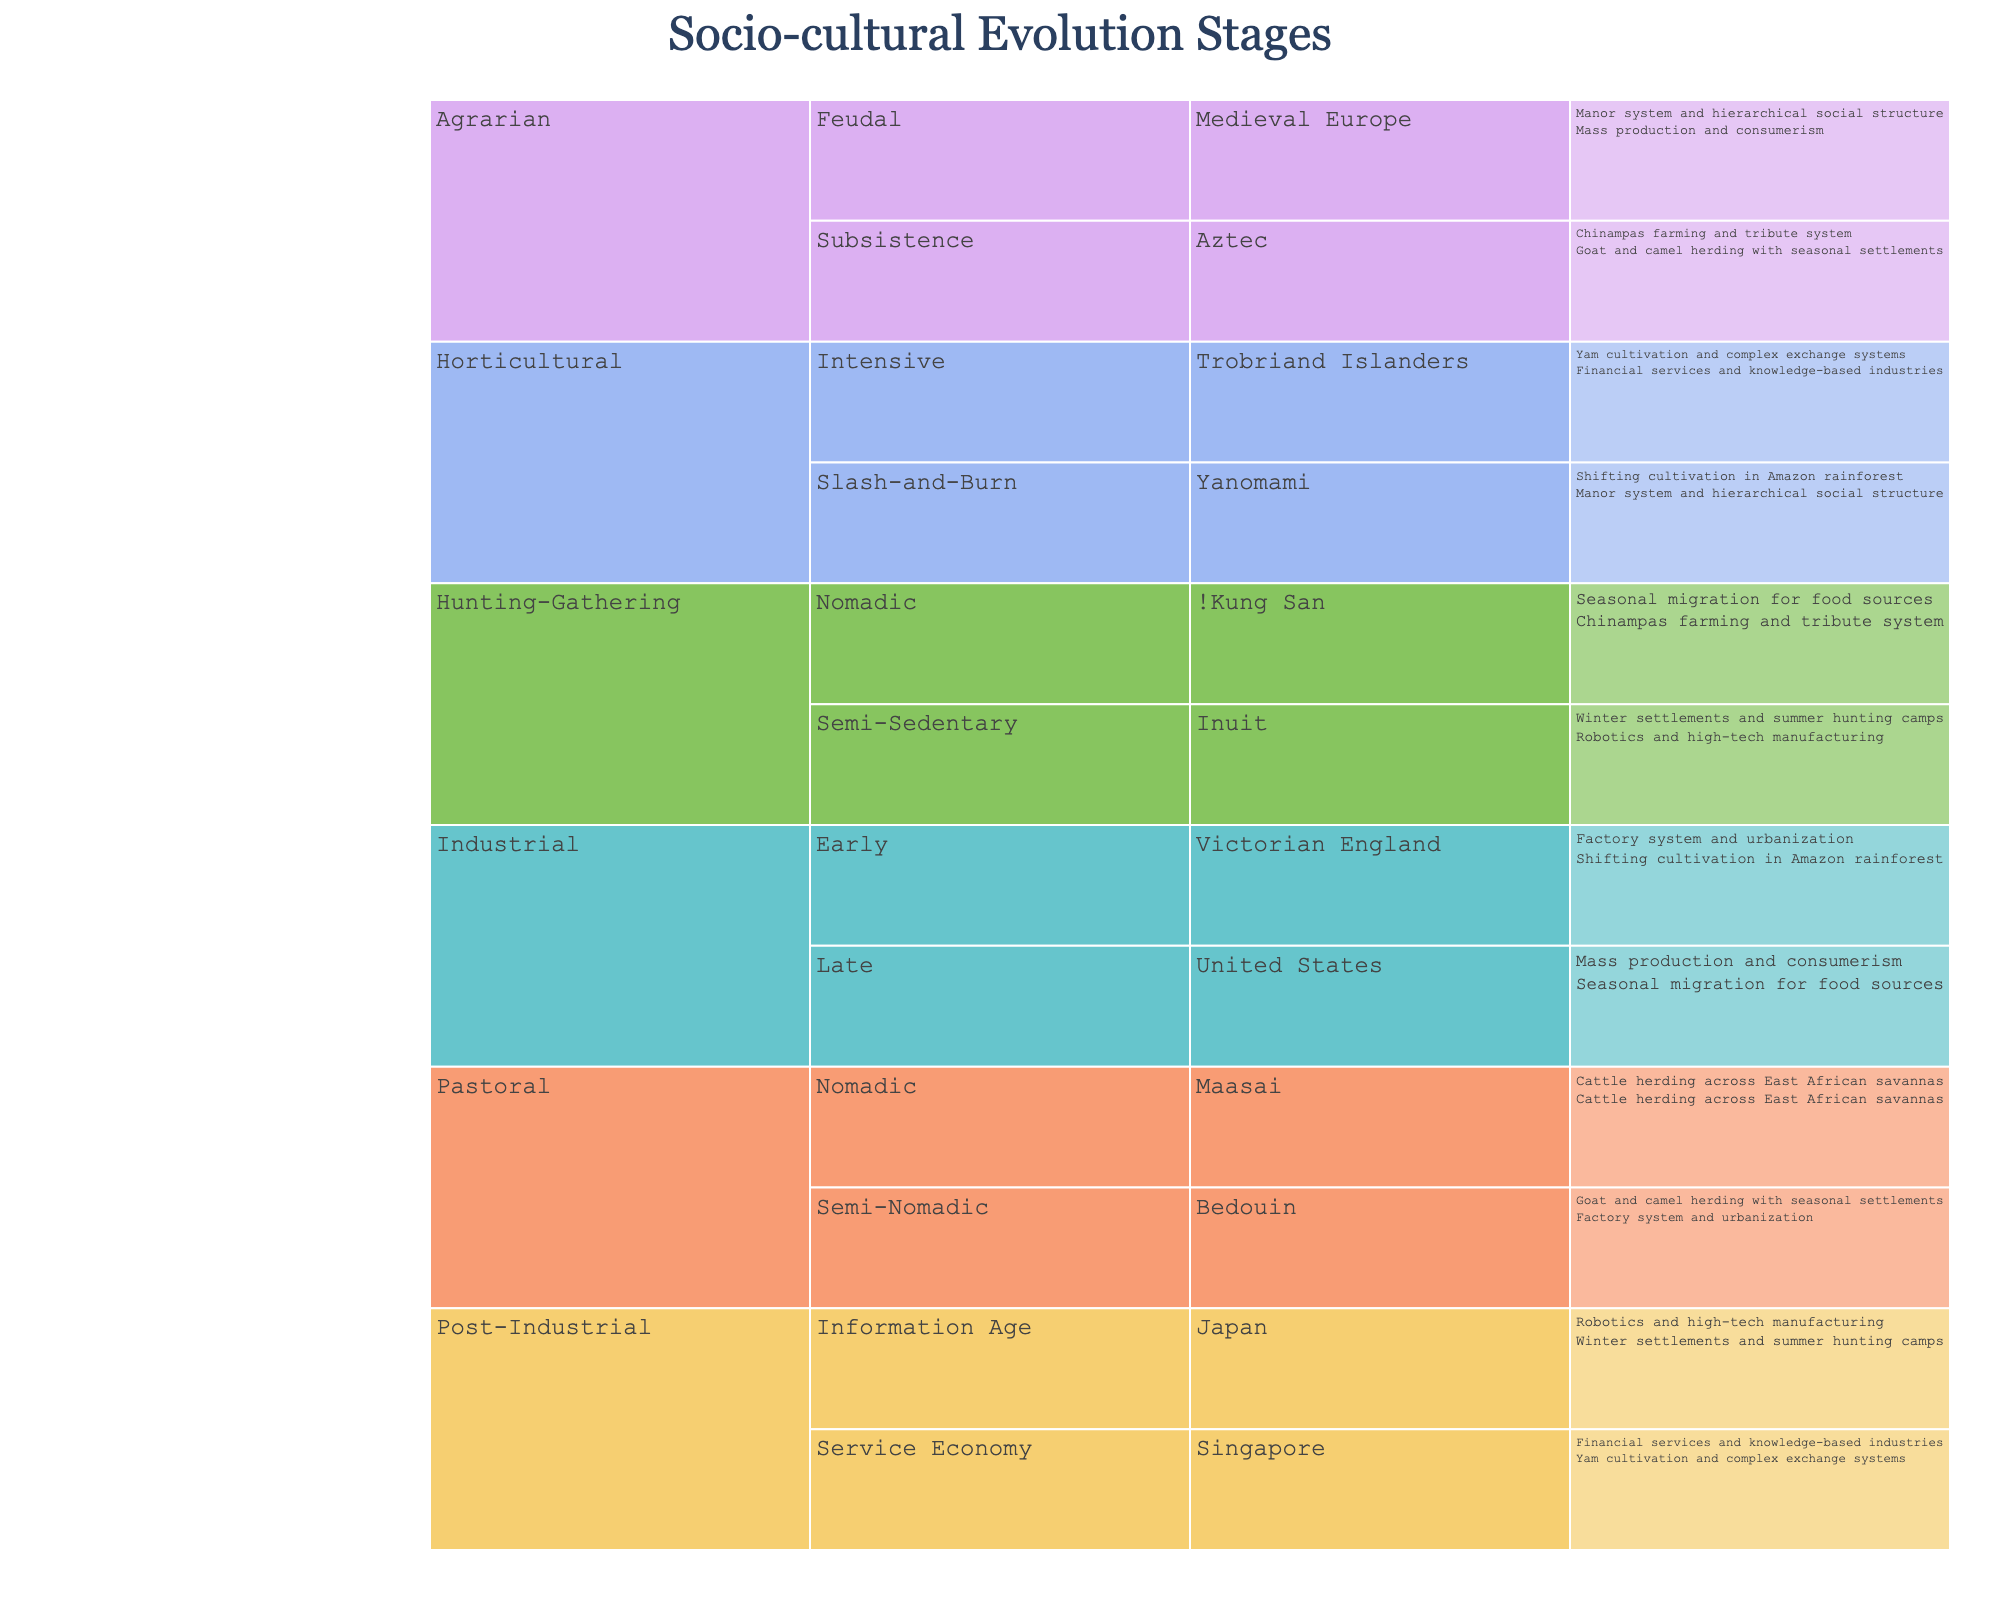How many main stages are there in the chart? The chart lists different social and cultural evolution stages, and by counting the main categories, we find five: Hunting-Gathering, Horticultural, Pastoral, Agrarian, Industrial, and Post-Industrial.
Answer: 6 Which society is associated with Slash-and-Burn Horticultural? By looking at the Icicle Chart, the Yanomami society is classified under the Slash-and-Burn sub-stage within the Horticultural stage.
Answer: Yanomami What are the two sub-stages under the Agrarian stage? The chart displays the sub-stages of the Agrarian stage by expanding it: Subsistence and Feudal.
Answer: Subsistence and Feudal Compare the activities associated with the Bedouin and Trobriand Islanders societies. How do they differ? The Bedouin society, under the Pastoral stage, Semi-Nomadic sub-stage, practices goat and camel herding with seasonal settlements, while the Trobriand Islanders, under Intensive Horticultural, focus on yam cultivation and complex exchange systems. These activities differ significantly: the former centers around herding, while the latter involves intensive agriculture and trade.
Answer: Bedouin: Goat and camel herding; Trobriand Islanders: Yam cultivation and complex exchange Which stage has societies practicing both subsistence farming and mass production? The Agrarian stage includes subsistence farming by the Aztecs, while the Industrial stage includes mass production by the United States. Additionally, by comparing these stages, we see both practices are represented across these distinct stages.
Answer: Agrarian and Industrial List all societies under the Post-Industrial stage and their respective examples. Under the Post-Industrial stage, there are two societies: Japan with robotics and high-tech manufacturing, and Singapore with financial services and knowledge-based industries.
Answer: Japan: robotics and high-tech manufacturing; Singapore: financial services and knowledge-based industries Which sub-stage under the Industrial stage represents early industrialization, and which society is an example? The early sub-stage of the Industrial stage is represented by Victorian England, which is associated with the factory system and urbanization.
Answer: Early: Victorian England How does the Trobriand Islanders' example of human activity differ from that of the Yanomami? The Trobriand Islanders practice yam cultivation and complex exchange systems under Intensive Horticultural, while the Yanomami practice shifting cultivation in the Amazon rainforest under Slash-and-Burn Horticultural. Shifting cultivation involves moving from one land patch to another, while intensive cultivation and trade involve more permanent agricultural processes and social structures.
Answer: Intensive cultivation and trade vs. shifting cultivation What example of human activity is associated with the United States in the chart? The Icicle Chart shows the United States under the Late Industrial stage with mass production and consumerism as the associated activities.
Answer: Mass production and consumerism 